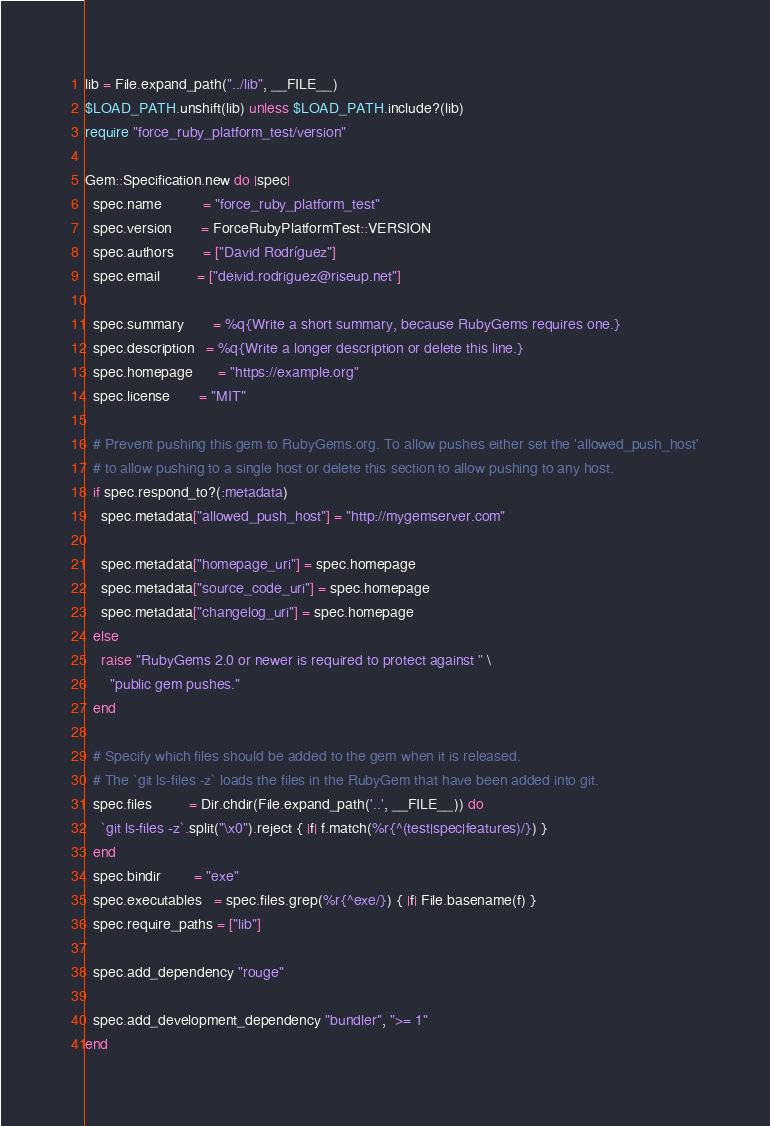Convert code to text. <code><loc_0><loc_0><loc_500><loc_500><_Ruby_>
lib = File.expand_path("../lib", __FILE__)
$LOAD_PATH.unshift(lib) unless $LOAD_PATH.include?(lib)
require "force_ruby_platform_test/version"

Gem::Specification.new do |spec|
  spec.name          = "force_ruby_platform_test"
  spec.version       = ForceRubyPlatformTest::VERSION
  spec.authors       = ["David Rodríguez"]
  spec.email         = ["deivid.rodriguez@riseup.net"]

  spec.summary       = %q{Write a short summary, because RubyGems requires one.}
  spec.description   = %q{Write a longer description or delete this line.}
  spec.homepage      = "https://example.org"
  spec.license       = "MIT"

  # Prevent pushing this gem to RubyGems.org. To allow pushes either set the 'allowed_push_host'
  # to allow pushing to a single host or delete this section to allow pushing to any host.
  if spec.respond_to?(:metadata)
    spec.metadata["allowed_push_host"] = "http://mygemserver.com"

    spec.metadata["homepage_uri"] = spec.homepage
    spec.metadata["source_code_uri"] = spec.homepage
    spec.metadata["changelog_uri"] = spec.homepage
  else
    raise "RubyGems 2.0 or newer is required to protect against " \
      "public gem pushes."
  end

  # Specify which files should be added to the gem when it is released.
  # The `git ls-files -z` loads the files in the RubyGem that have been added into git.
  spec.files         = Dir.chdir(File.expand_path('..', __FILE__)) do
    `git ls-files -z`.split("\x0").reject { |f| f.match(%r{^(test|spec|features)/}) }
  end
  spec.bindir        = "exe"
  spec.executables   = spec.files.grep(%r{^exe/}) { |f| File.basename(f) }
  spec.require_paths = ["lib"]

  spec.add_dependency "rouge"

  spec.add_development_dependency "bundler", ">= 1"
end
</code> 